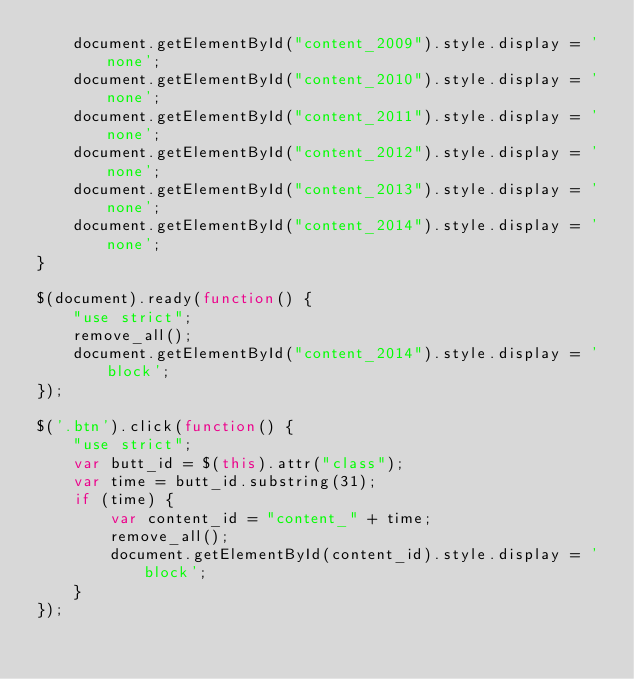Convert code to text. <code><loc_0><loc_0><loc_500><loc_500><_JavaScript_>    document.getElementById("content_2009").style.display = 'none';
    document.getElementById("content_2010").style.display = 'none';
    document.getElementById("content_2011").style.display = 'none';
    document.getElementById("content_2012").style.display = 'none';
    document.getElementById("content_2013").style.display = 'none';
    document.getElementById("content_2014").style.display = 'none';
}

$(document).ready(function() {
    "use strict";
    remove_all();
    document.getElementById("content_2014").style.display = 'block';
});

$('.btn').click(function() {
    "use strict";
    var butt_id = $(this).attr("class");
    var time = butt_id.substring(31);
    if (time) {
        var content_id = "content_" + time;
        remove_all();
        document.getElementById(content_id).style.display = 'block';
    }
});</code> 